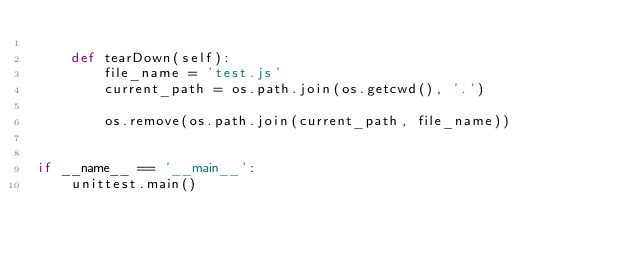<code> <loc_0><loc_0><loc_500><loc_500><_Python_>
    def tearDown(self):
        file_name = 'test.js'
        current_path = os.path.join(os.getcwd(), '.')

        os.remove(os.path.join(current_path, file_name))


if __name__ == '__main__':
    unittest.main()
</code> 